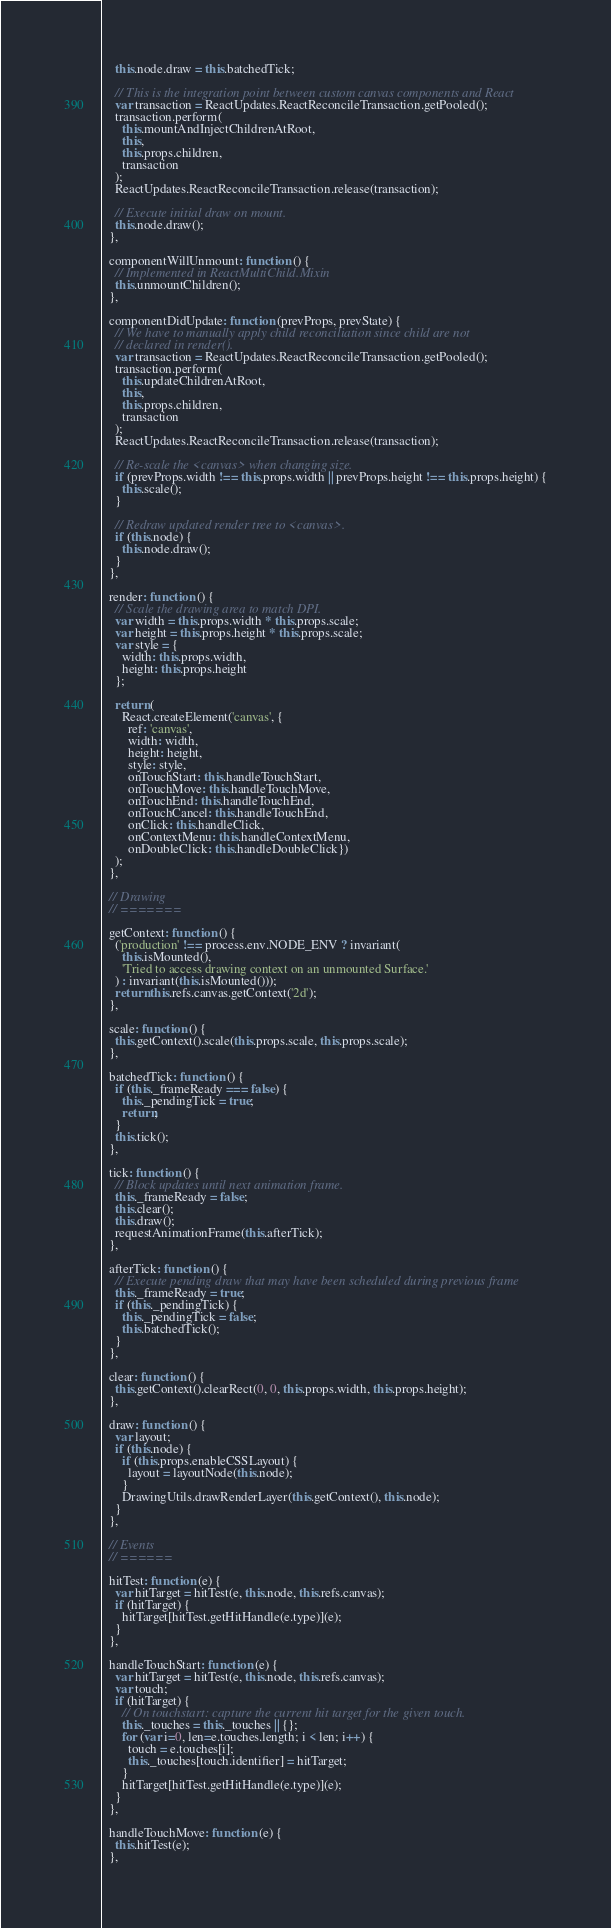<code> <loc_0><loc_0><loc_500><loc_500><_JavaScript_>    this.node.draw = this.batchedTick;

    // This is the integration point between custom canvas components and React
    var transaction = ReactUpdates.ReactReconcileTransaction.getPooled();
    transaction.perform(
      this.mountAndInjectChildrenAtRoot,
      this,
      this.props.children,
      transaction
    );
    ReactUpdates.ReactReconcileTransaction.release(transaction);

    // Execute initial draw on mount.
    this.node.draw();
  },

  componentWillUnmount: function () {
    // Implemented in ReactMultiChild.Mixin
    this.unmountChildren();
  },

  componentDidUpdate: function (prevProps, prevState) {
    // We have to manually apply child reconciliation since child are not
    // declared in render().
    var transaction = ReactUpdates.ReactReconcileTransaction.getPooled();
    transaction.perform(
      this.updateChildrenAtRoot,
      this,
      this.props.children,
      transaction
    );
    ReactUpdates.ReactReconcileTransaction.release(transaction);

    // Re-scale the <canvas> when changing size.
    if (prevProps.width !== this.props.width || prevProps.height !== this.props.height) {
      this.scale();
    }

    // Redraw updated render tree to <canvas>.
    if (this.node) {
      this.node.draw();
    }
  },

  render: function () {
    // Scale the drawing area to match DPI.
    var width = this.props.width * this.props.scale;
    var height = this.props.height * this.props.scale;
    var style = {
      width: this.props.width,
      height: this.props.height
    };

    return (
      React.createElement('canvas', {
        ref: 'canvas',
        width: width,
        height: height,
        style: style,
        onTouchStart: this.handleTouchStart,
        onTouchMove: this.handleTouchMove,
        onTouchEnd: this.handleTouchEnd,
        onTouchCancel: this.handleTouchEnd,
        onClick: this.handleClick,
        onContextMenu: this.handleContextMenu,
        onDoubleClick: this.handleDoubleClick})
    );
  },

  // Drawing
  // =======

  getContext: function () {
    ('production' !== process.env.NODE_ENV ? invariant(
      this.isMounted(),
      'Tried to access drawing context on an unmounted Surface.'
    ) : invariant(this.isMounted()));
    return this.refs.canvas.getContext('2d');
  },

  scale: function () {
    this.getContext().scale(this.props.scale, this.props.scale);
  },

  batchedTick: function () {
    if (this._frameReady === false) {
      this._pendingTick = true;
      return;
    }
    this.tick();
  },

  tick: function () {
    // Block updates until next animation frame.
    this._frameReady = false;
    this.clear();
    this.draw();
    requestAnimationFrame(this.afterTick);
  },

  afterTick: function () {
    // Execute pending draw that may have been scheduled during previous frame
    this._frameReady = true;
    if (this._pendingTick) {
      this._pendingTick = false;
      this.batchedTick();
    }
  },

  clear: function () {
    this.getContext().clearRect(0, 0, this.props.width, this.props.height);
  },

  draw: function () {
    var layout;
    if (this.node) {
      if (this.props.enableCSSLayout) {
        layout = layoutNode(this.node);
      }
      DrawingUtils.drawRenderLayer(this.getContext(), this.node);
    }
  },

  // Events
  // ======

  hitTest: function (e) {
    var hitTarget = hitTest(e, this.node, this.refs.canvas);
    if (hitTarget) {
      hitTarget[hitTest.getHitHandle(e.type)](e);
    }
  },

  handleTouchStart: function (e) {
    var hitTarget = hitTest(e, this.node, this.refs.canvas);
    var touch;
    if (hitTarget) {
      // On touchstart: capture the current hit target for the given touch.
      this._touches = this._touches || {};
      for (var i=0, len=e.touches.length; i < len; i++) {
        touch = e.touches[i];
        this._touches[touch.identifier] = hitTarget;
      }
      hitTarget[hitTest.getHitHandle(e.type)](e);
    }
  },

  handleTouchMove: function (e) {
    this.hitTest(e);
  },
</code> 